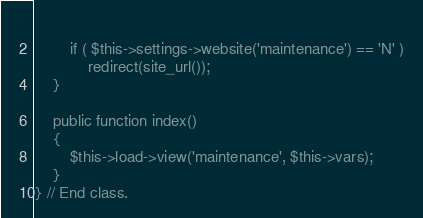Convert code to text. <code><loc_0><loc_0><loc_500><loc_500><_PHP_>		
		if ( $this->settings->website('maintenance') == 'N' )
			redirect(site_url());
	}
	
	public function index()
	{
		$this->load->view('maintenance', $this->vars);
	}
} // End class.</code> 